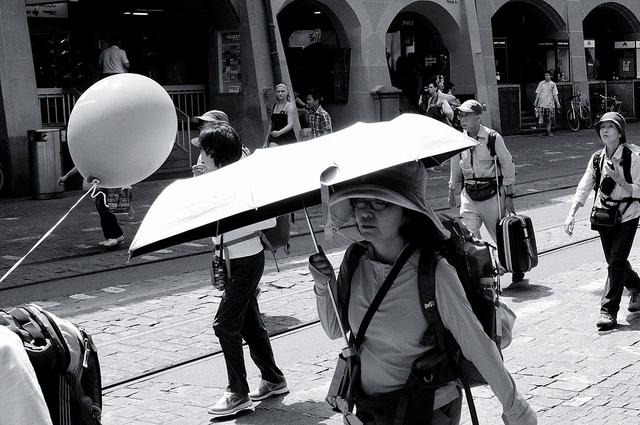Is the woman's hair held by a hair clip?
Concise answer only. No. Are they coming back from a surfing trip?
Answer briefly. No. What is the lady wearing?
Short answer required. Hat. Is the a bike in a picture?
Short answer required. Yes. What is the woman shielding herself from by using the umbrella?
Concise answer only. Sun. Is this the beach?
Give a very brief answer. No. Is the umbrella for sun or rain?
Quick response, please. Sun. What is the man in the foreground carrying?
Be succinct. Umbrella. Is the photo black and white?
Be succinct. Yes. What is written on the trash can?
Quick response, please. Nothing. Does the balloon have a hole in it?
Keep it brief. No. Where is the man standing?
Short answer required. Sidewalk. 